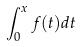<formula> <loc_0><loc_0><loc_500><loc_500>\int _ { 0 } ^ { x } f ( t ) d t</formula> 